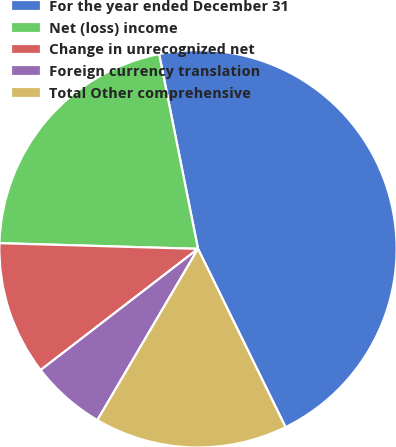Convert chart to OTSL. <chart><loc_0><loc_0><loc_500><loc_500><pie_chart><fcel>For the year ended December 31<fcel>Net (loss) income<fcel>Change in unrecognized net<fcel>Foreign currency translation<fcel>Total Other comprehensive<nl><fcel>45.87%<fcel>21.41%<fcel>10.9%<fcel>6.1%<fcel>15.72%<nl></chart> 